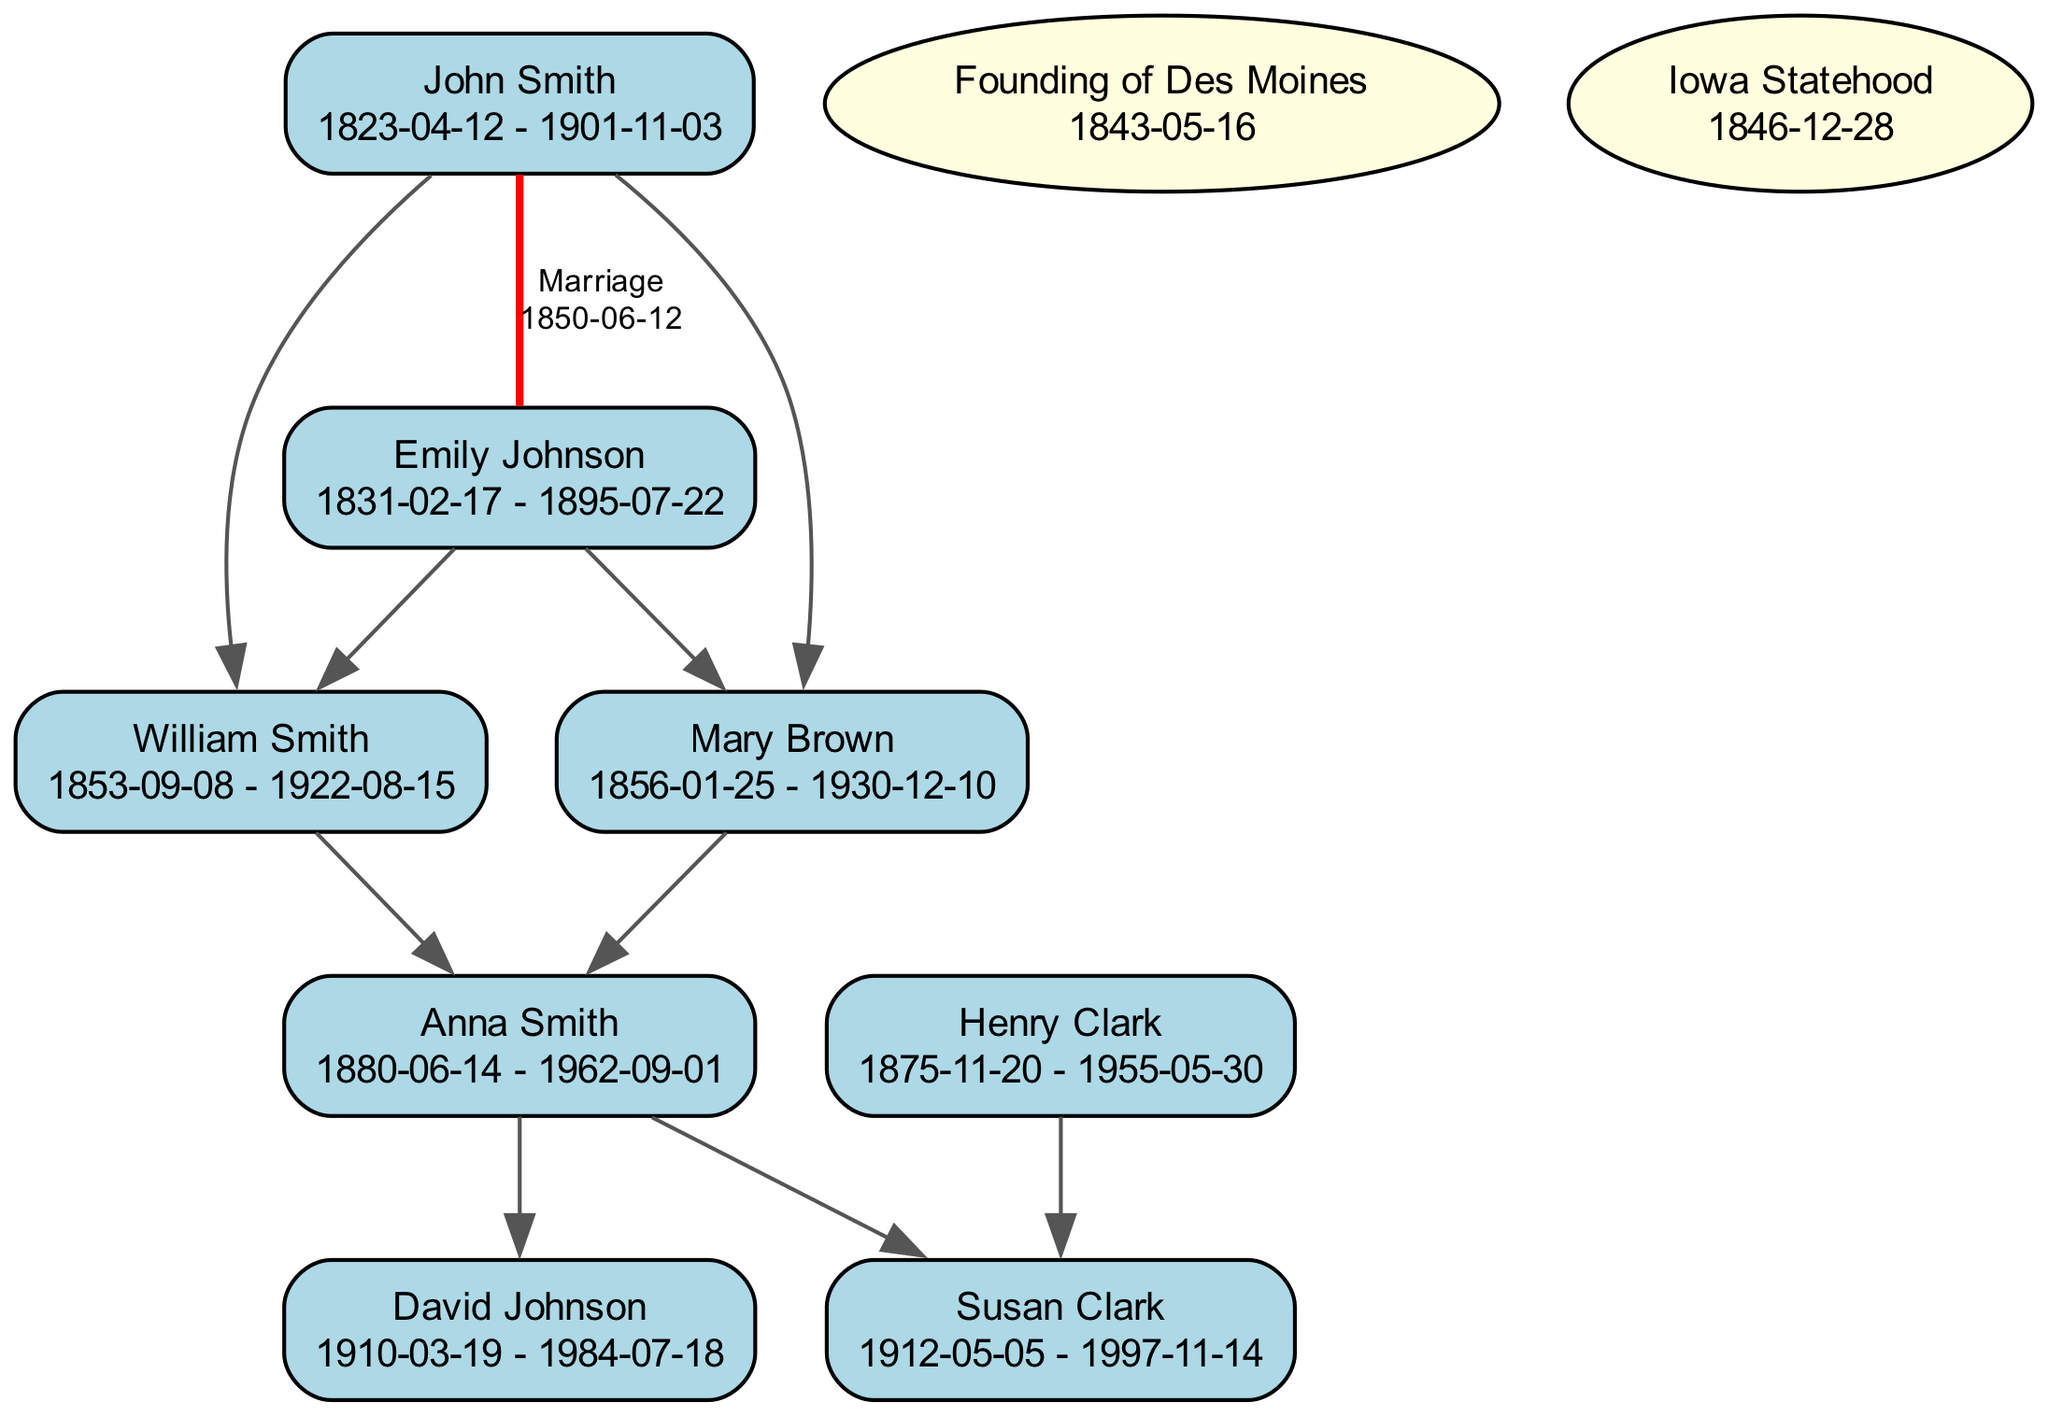What is the birthdate of John Smith? The birthdate of John Smith can be found in the diagram under his name, which clearly states "1823-04-12."
Answer: 1823-04-12 Who were the parents of Anna Smith? To find the parents of Anna Smith, we can trace the lines connecting her to her parent nodes, which are William Smith and Mary Brown, as indicated by the parent relationship.
Answer: William Smith and Mary Brown What event occurred on December 28, 1846? The diagram lists significant events, and on this date, the notation specifies "Iowa Statehood," indicating that this event is highlighted in the timeline of the genealogical tree.
Answer: Iowa Statehood How many children did John Smith and Emily Johnson have together? By analyzing the parent relationships stemming from John Smith and Emily Johnson, we can see that they had two children: William Smith and Mary Brown, who are directly connected to them in the diagram.
Answer: 2 What is the relationship between David Johnson and Emily Johnson? The diagram shows that David Johnson is a child of Anna Smith, who is a child of William Smith and Emily Johnson. Thus, David Johnson is the grandchild of Emily Johnson.
Answer: Grandchild Which event took place first: Founding of Des Moines or Iowa Statehood? Comparing the dates in the events section, we note that Founding of Des Moines occurred on May 16, 1843, while Iowa Statehood happened later on December 28, 1846. Therefore, the former event occurred first.
Answer: Founding of Des Moines How many marriages are represented in the diagram? The diagram indicates one marriage between John Smith and Emily Johnson, as denoted by the red edge labeled "Marriage" connecting them, thus representing a single marriage relationship.
Answer: 1 What is the death date of Susan Clark? The death date of Susan Clark can be located in the diagram, which states "1997-11-14" under her name within the node.
Answer: 1997-11-14 